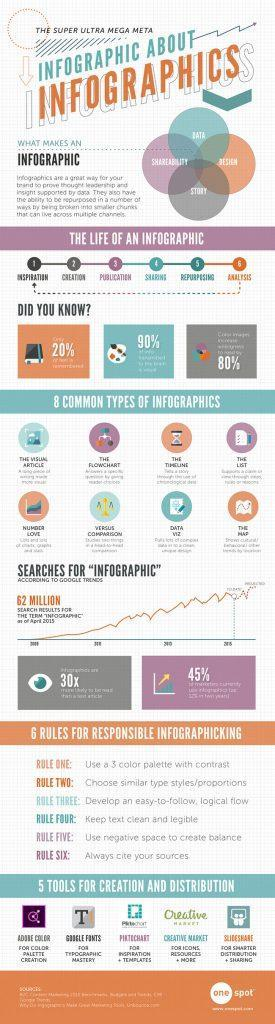What is the third rule in making an infographic?
Answer the question with a short phrase. Develop an easy-to-folllow, logical flow What is the fourth stage in the creation of an infographic? Sharing Which tool can be used for Inspiration templates while making infographics? PintoChart What is the final stage in the creation of an infographic? Analysis What is the usage of the fourth tool listed for creating an infographic? For Icons, Resources + More Which is the fifth type of Infographic listed? Number Love What are the elements that makes an infographic other than "Story"? Data, Shareability, Design What is the third stage in the creation of an infographic? Publication Which is the tool used for Typographic mastery? Google Fonts Which is the seventh type of Infographic listed? Data Viz 